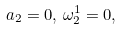Convert formula to latex. <formula><loc_0><loc_0><loc_500><loc_500>a _ { 2 } = 0 , \, \omega _ { 2 } ^ { 1 } = 0 ,</formula> 